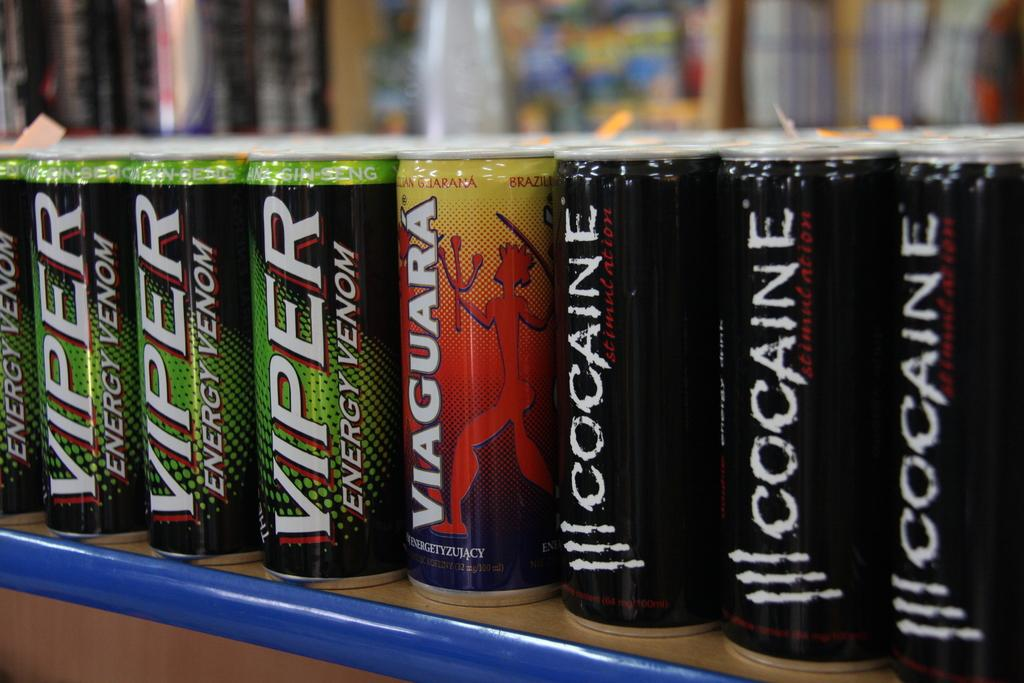<image>
Render a clear and concise summary of the photo. A variety of drinks of different brands are displayed side by side with one being Viper energy venom branded. 